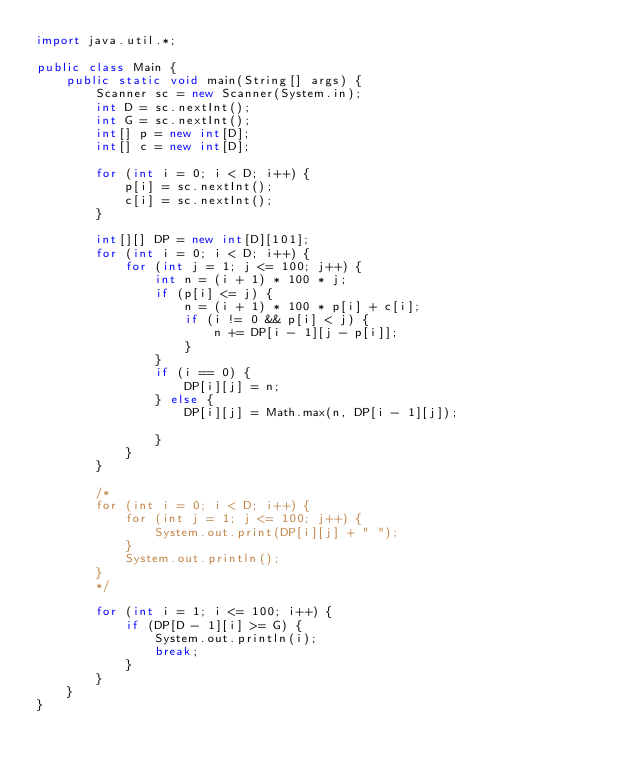<code> <loc_0><loc_0><loc_500><loc_500><_Java_>import java.util.*;

public class Main {
    public static void main(String[] args) {
        Scanner sc = new Scanner(System.in);
        int D = sc.nextInt();
        int G = sc.nextInt();
        int[] p = new int[D];
        int[] c = new int[D];

        for (int i = 0; i < D; i++) {
            p[i] = sc.nextInt();
            c[i] = sc.nextInt();
        }

        int[][] DP = new int[D][101];
        for (int i = 0; i < D; i++) {
            for (int j = 1; j <= 100; j++) {
                int n = (i + 1) * 100 * j;
                if (p[i] <= j) {
                    n = (i + 1) * 100 * p[i] + c[i];
                    if (i != 0 && p[i] < j) {
                        n += DP[i - 1][j - p[i]];
                    }
                }
                if (i == 0) {
                    DP[i][j] = n;
                } else {
                    DP[i][j] = Math.max(n, DP[i - 1][j]);

                }
            }
        }

        /*
        for (int i = 0; i < D; i++) {
            for (int j = 1; j <= 100; j++) {
                System.out.print(DP[i][j] + " ");
            }
            System.out.println();
        }
        */

        for (int i = 1; i <= 100; i++) {
            if (DP[D - 1][i] >= G) {
                System.out.println(i);
                break;
            }
        }
    }
}
</code> 